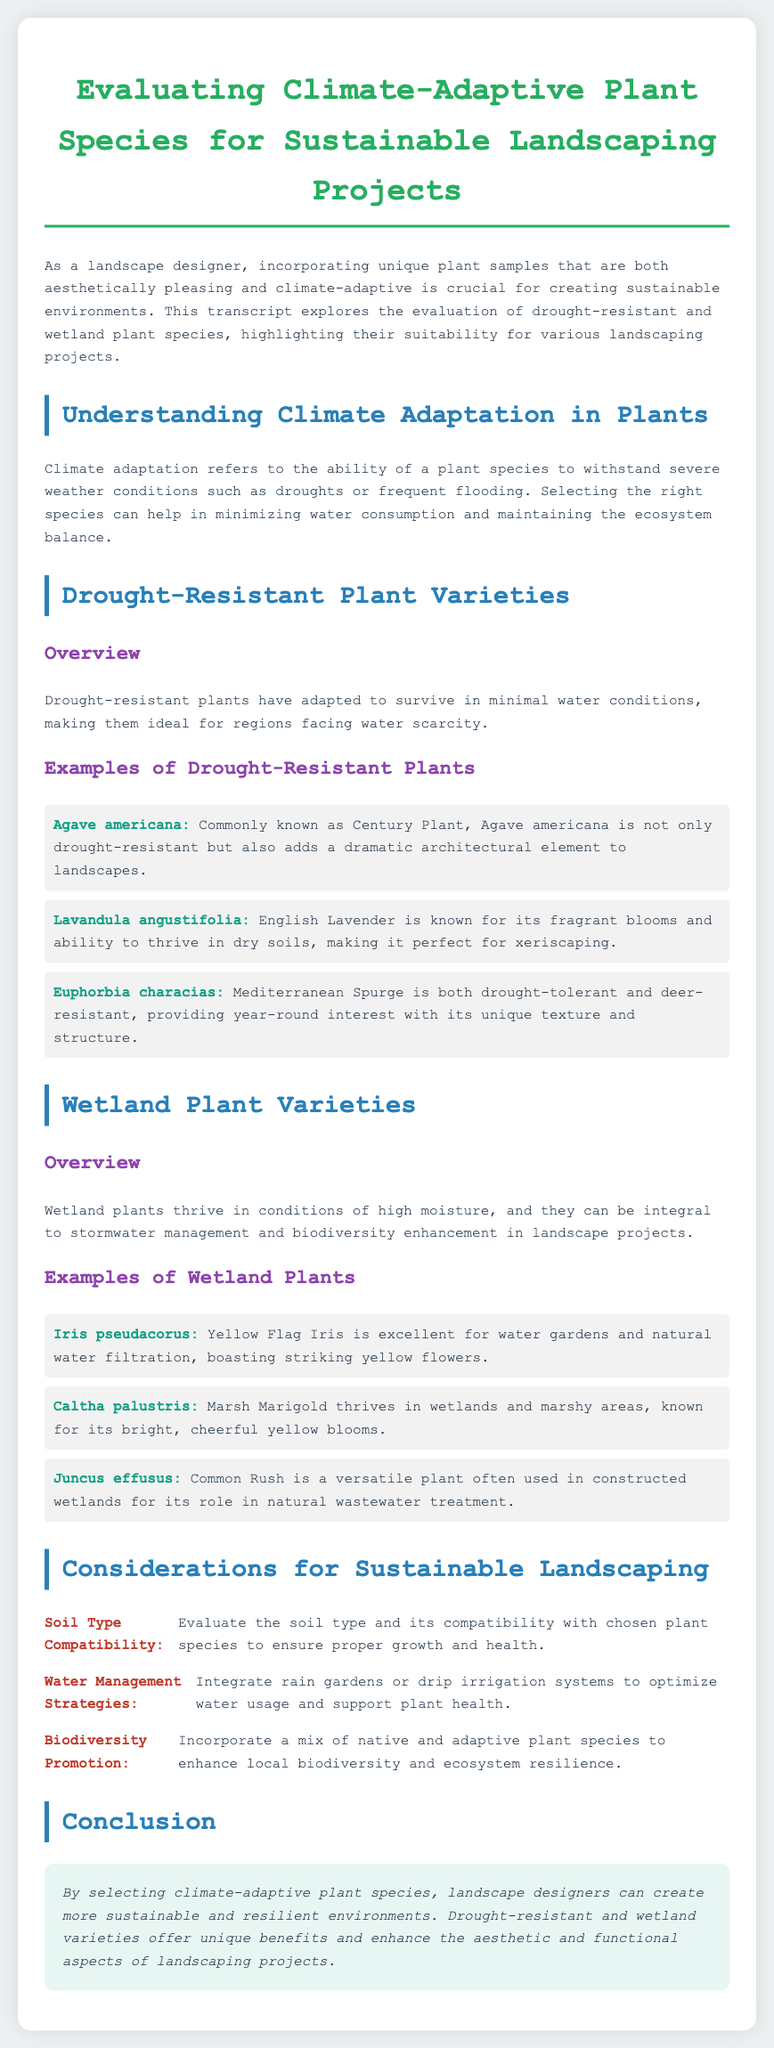what is the title of the document? The title of the document is prominently displayed at the top and is "Evaluating Climate-Adaptive Plant Species for Sustainable Landscaping Projects."
Answer: Evaluating Climate-Adaptive Plant Species for Sustainable Landscaping Projects how many examples of drought-resistant plants are provided? The document lists three examples of drought-resistant plants under the section "Examples of Drought-Resistant Plants."
Answer: 3 what is the common name of Agave americana? The document clearly states that Agave americana is commonly known as the Century Plant.
Answer: Century Plant which plant is excellent for water gardens? Under the "Examples of Wetland Plants," the document mentions that Iris pseudacorus is excellent for water gardens.
Answer: Iris pseudacorus what is a key consideration for sustainable landscaping mentioned in the document? The document outlines several considerations, one of which is "Soil Type Compatibility."
Answer: Soil Type Compatibility which plant is known for bright yellow blooms? The document indicates that Caltha palustris, also known as Marsh Marigold, is known for its bright yellow blooms.
Answer: Caltha palustris what color are the flowers of Iris pseudacorus? It is stated in the document that Iris pseudacorus boasts striking yellow flowers.
Answer: yellow what is one of the recommended water management strategies? The document suggests integrating rain gardens or drip irrigation systems.
Answer: rain gardens or drip irrigation systems 